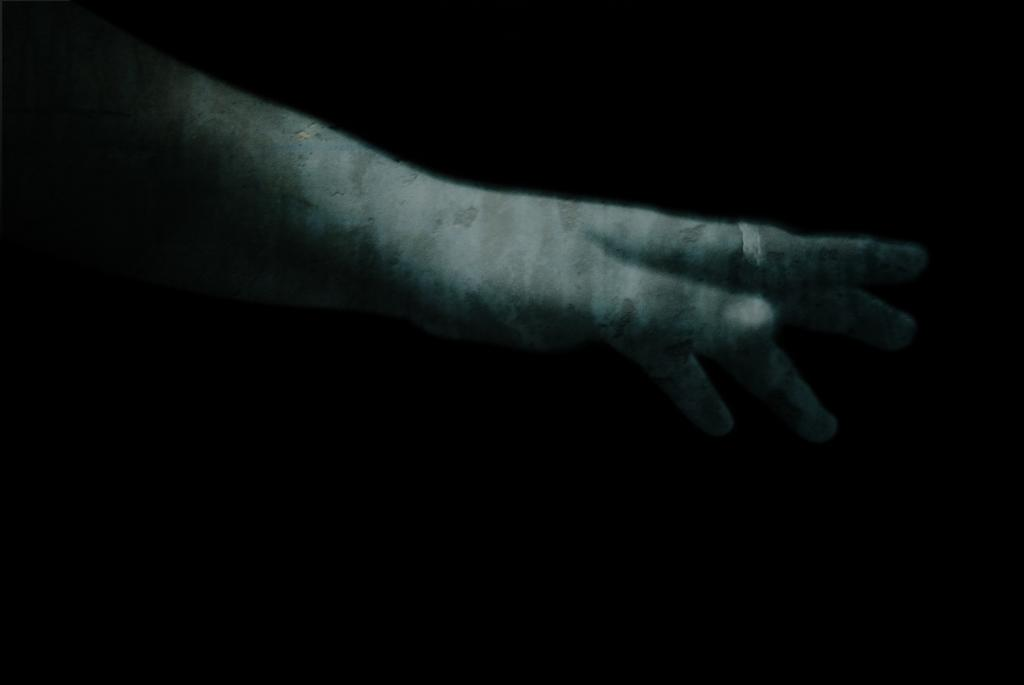What part of the human body is visible in the image? There is a human hand in the image. Are there any accessories on the hand? Yes, the hand has a ring on one of its fingers. What can be observed about the background of the image? The background of the image is completely dark. How many horses are visible in the image? There are no horses present in the image. Is there a tent in the image? There is no tent present in the image. 